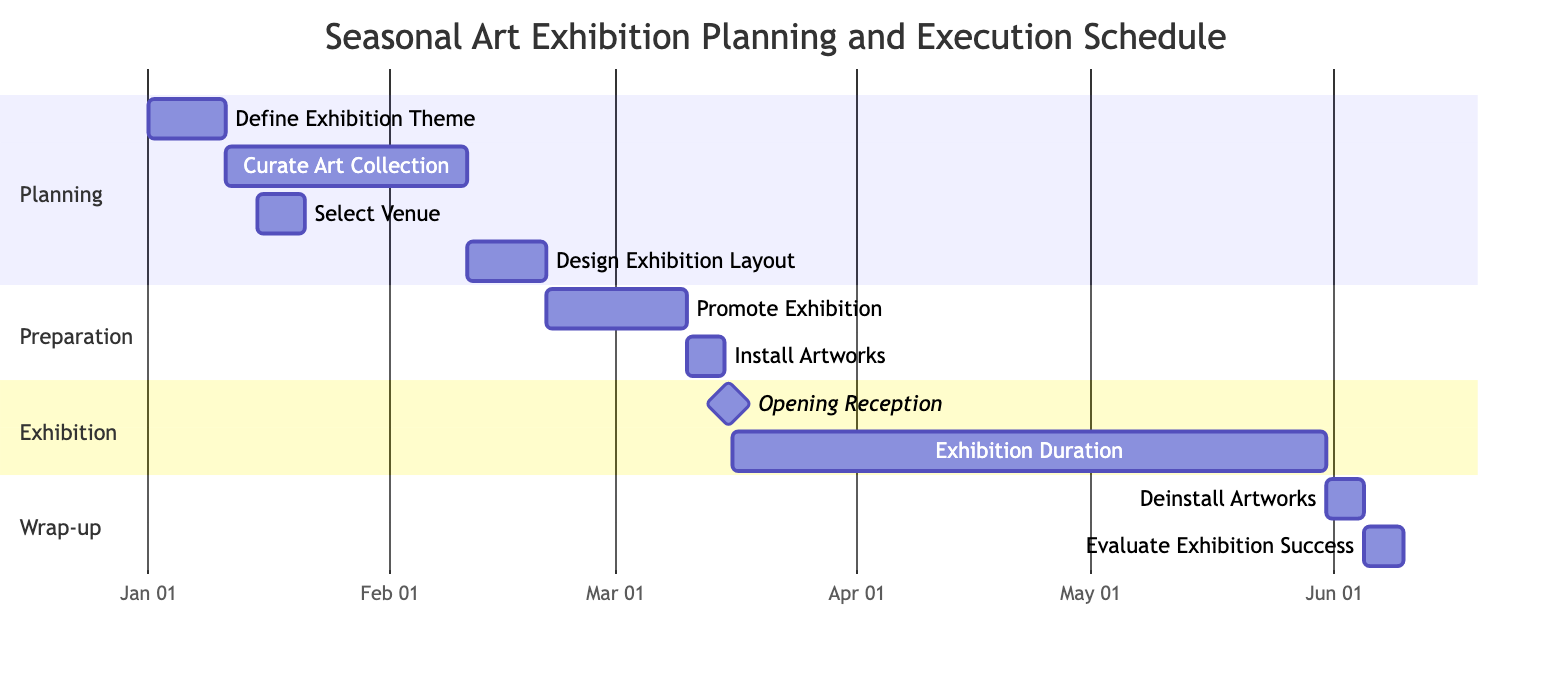What is the start date of the "Curate Art Collection" task? The "Curate Art Collection" task starts after the "Define Exhibition Theme" task, which ends on January 10, 2024. Thus, the "Curate Art Collection" task starts on January 11, 2024.
Answer: January 11, 2024 How many days is the "Exhibition Duration"? The "Exhibition Duration" starts on March 17, 2024, and ends on May 31, 2024. The total number of days can be calculated by counting the days from March 17 to May 31, which is 76 days.
Answer: 76 days What task follows the "Promote Exhibition"? According to the diagram, the task that follows "Promote Exhibition" is "Install Artworks," which starts after the promotion ends.
Answer: Install Artworks What is the milestone date for the "Opening Reception"? The "Opening Reception" is a milestone task that occurs on a single day, which is March 16, 2024.
Answer: March 16, 2024 Which task has the longest duration? The task "Curate Art Collection" spans from January 11, 2024, to February 10, 2024, covering a duration of 31 days, which is the longest among all tasks in the diagram.
Answer: Curate Art Collection When does the "Evaluate Exhibition Success" task start? The "Evaluate Exhibition Success" task starts after "Deinstall Artworks" is completed, which ends on June 5, 2024. Therefore, it starts on June 6, 2024.
Answer: June 6, 2024 Which section contains the "Design Exhibition Layout"? The "Design Exhibition Layout" task is included in the "Planning" section of the Gantt chart.
Answer: Planning How many tasks are in the "Preparation" section? The "Preparation" section includes two tasks: "Promote Exhibition" and "Install Artworks." Thus, there are two tasks in this section.
Answer: 2 